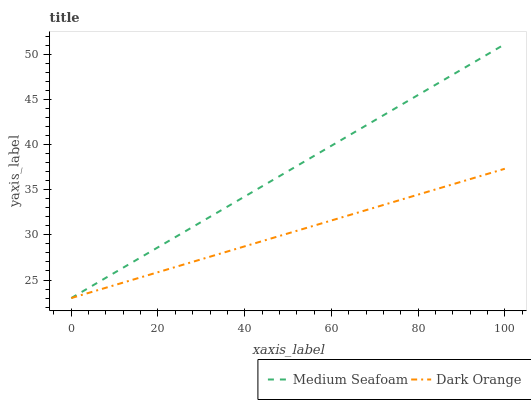Does Dark Orange have the minimum area under the curve?
Answer yes or no. Yes. Does Medium Seafoam have the maximum area under the curve?
Answer yes or no. Yes. Does Medium Seafoam have the minimum area under the curve?
Answer yes or no. No. Is Dark Orange the smoothest?
Answer yes or no. Yes. Is Medium Seafoam the roughest?
Answer yes or no. Yes. Is Medium Seafoam the smoothest?
Answer yes or no. No. Does Dark Orange have the lowest value?
Answer yes or no. Yes. Does Medium Seafoam have the highest value?
Answer yes or no. Yes. Does Medium Seafoam intersect Dark Orange?
Answer yes or no. Yes. Is Medium Seafoam less than Dark Orange?
Answer yes or no. No. Is Medium Seafoam greater than Dark Orange?
Answer yes or no. No. 